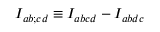<formula> <loc_0><loc_0><loc_500><loc_500>I _ { a b ; c d } \equiv I _ { a b c d } - I _ { a b d c }</formula> 